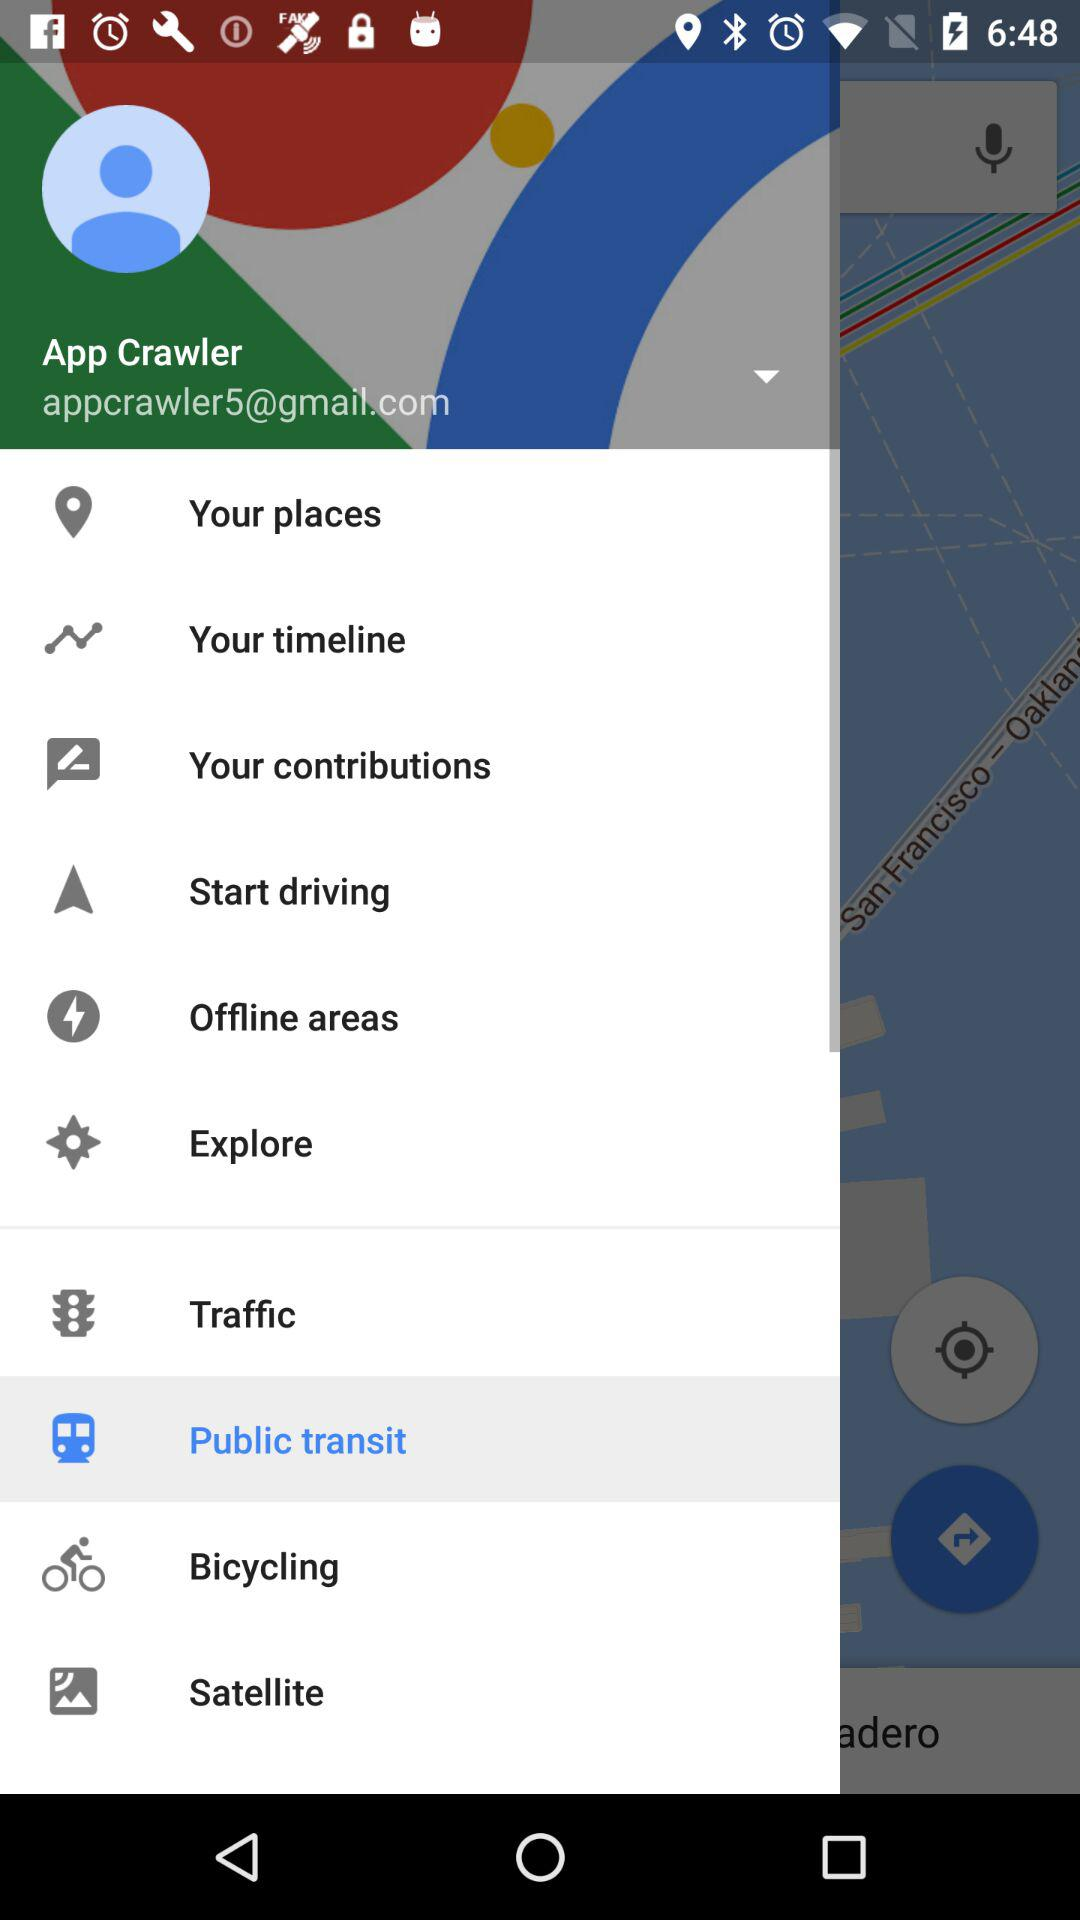What is the user name? The user name is App Crawler. 